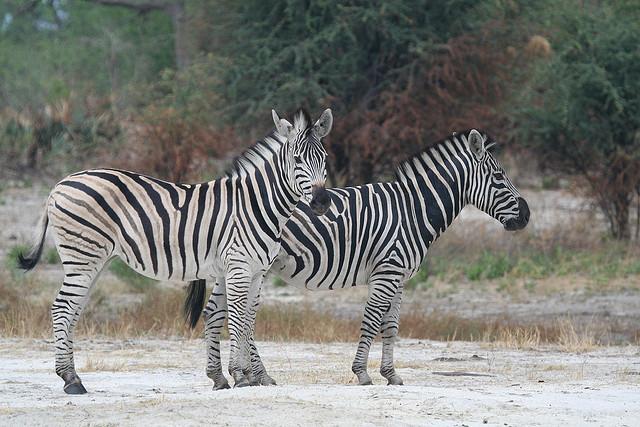Can you see the zebras' shadows?
Give a very brief answer. No. Are these zebras playing or fighting?
Write a very short answer. Playing. Is it day or night?
Write a very short answer. Day. What is the zebra looking at?
Give a very brief answer. Camera. Are the animals going for a walk?
Be succinct. No. What is the zebra standing on?
Be succinct. Dirt. What is the relation of the Zebras?
Keep it brief. Siblings. How many colors are used in this picture?
Short answer required. 5. Are these animals in the mountains?
Keep it brief. No. How many animals here?
Concise answer only. 2. How many zebras are laying down?
Answer briefly. 0. Is the zebra trying to eat?
Write a very short answer. No. What is below the zebra?
Write a very short answer. Sand. Is the baby zebra under the bigger zebra?
Answer briefly. No. Are the zebras in the picture in captivity?
Short answer required. No. Is this animal eating grass?
Keep it brief. No. Is the grass green?
Be succinct. No. Are the zebras in motion?
Write a very short answer. No. Are both animals adults?
Short answer required. Yes. Do these zebra have the same exact pattern?
Keep it brief. No. What is a group of these animals called?
Quick response, please. Herd. What are the zebras doing?
Quick response, please. Standing. Are the zebras hugging each other?
Quick response, please. No. How many zebras are there?
Keep it brief. 2. Are these animals hungry?
Concise answer only. No. Are the zebras hungry?
Answer briefly. No. The number of animals is?
Write a very short answer. 2. 